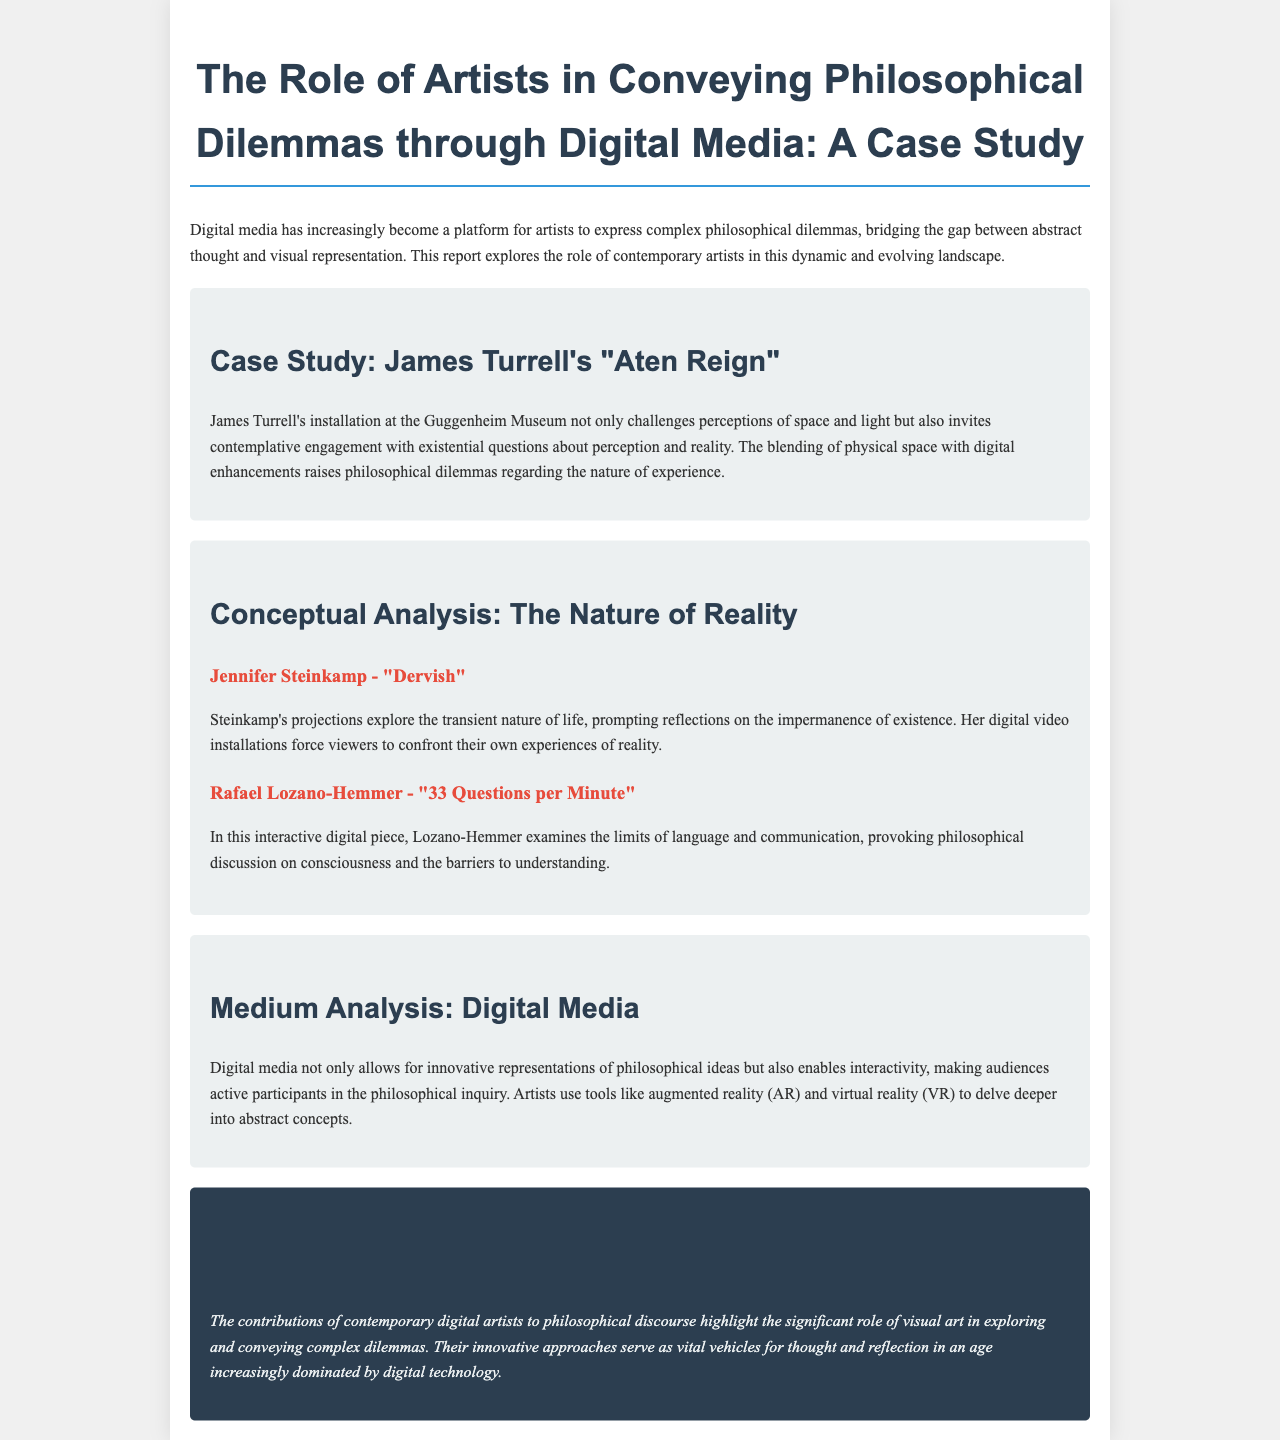What is the title of the report? The title of the report is provided in the header section of the document.
Answer: The Role of Artists in Conveying Philosophical Dilemmas through Digital Media: A Case Study Who is the artist featured in the case study? The case study highlights the work of a specific artist, which is mentioned in the text.
Answer: James Turrell What installation is discussed in the case study? The installation discussed is named in the heading of the case study section.
Answer: Aten Reign What philosophical concept is explored by Jennifer Steinkamp? The text describes what concept Steinkamp's work prompts viewers to reflect on.
Answer: Impermanence What does Rafael Lozano-Hemmer's piece examine? This question seeks to identify the theme of Lozano-Hemmer's digital piece as detailed in the document.
Answer: Limits of language and communication How does digital media affect audience participation? The document discusses the impact of digital media on viewer engagement with philosophical ideas.
Answer: Enables interactivity What is the nature of reality emphasized in the report? The report highlights a key philosophical topic that ties the artists' work together.
Answer: The Nature of Reality What year did the report likely reference for contemporary artists? The context indicates a general time frame related to the artists mentioned in the report.
Answer: Contemporary What feature of digital media allows exploration of abstract concepts? The report outlines a critical capability of digital media highlighted in the analysis section.
Answer: Interactivity 